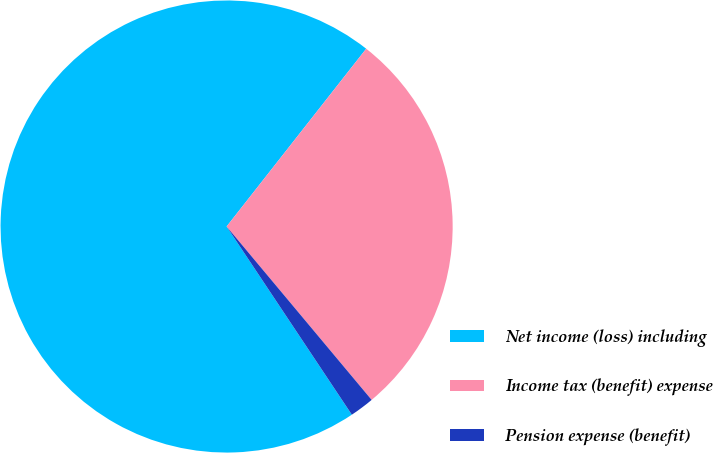<chart> <loc_0><loc_0><loc_500><loc_500><pie_chart><fcel>Net income (loss) including<fcel>Income tax (benefit) expense<fcel>Pension expense (benefit)<nl><fcel>69.94%<fcel>28.32%<fcel>1.74%<nl></chart> 